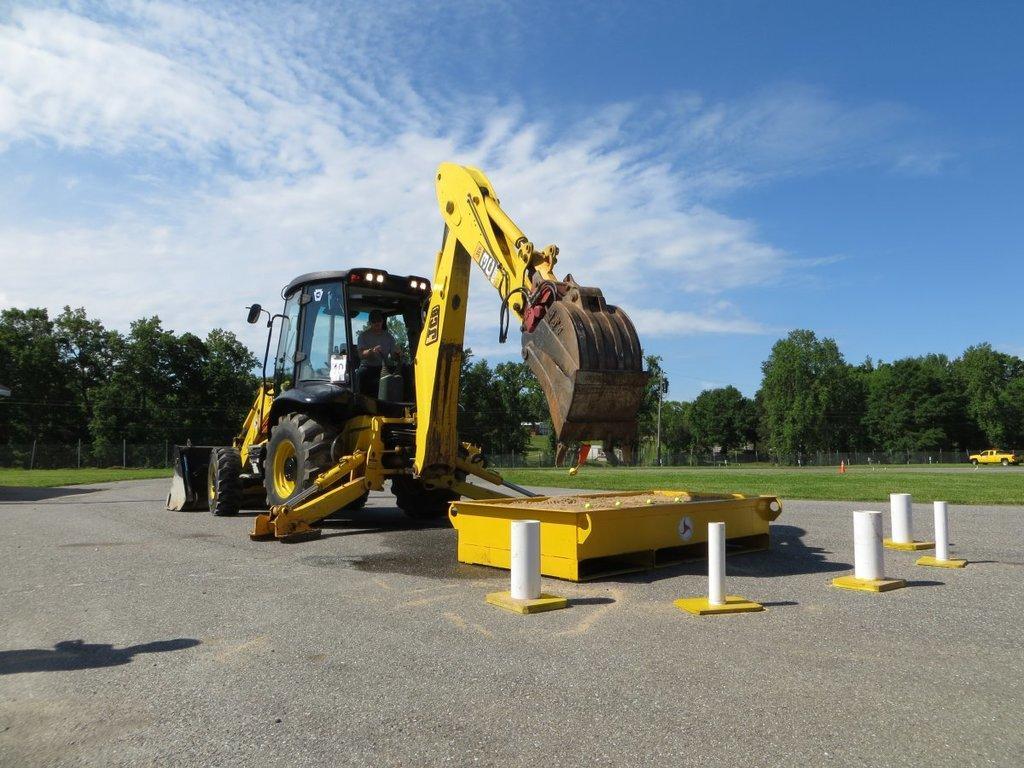How would you summarize this image in a sentence or two? In this picture I can see a crane and few trees and I can see mini truck and grass on the ground and it looks like a small metal container on the road and a blue cloudy sky. 